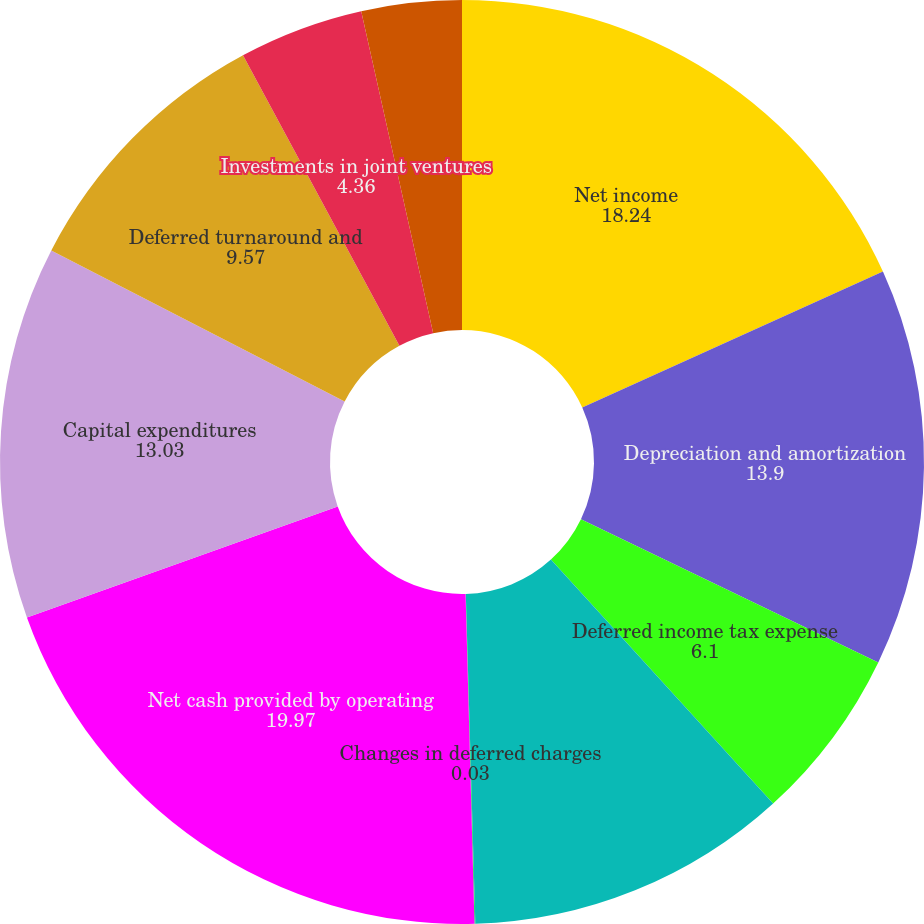<chart> <loc_0><loc_0><loc_500><loc_500><pie_chart><fcel>Net income<fcel>Depreciation and amortization<fcel>Deferred income tax expense<fcel>Changes in current assets and<fcel>Changes in deferred charges<fcel>Net cash provided by operating<fcel>Capital expenditures<fcel>Deferred turnaround and<fcel>Investments in joint ventures<fcel>Other investing activities net<nl><fcel>18.24%<fcel>13.9%<fcel>6.1%<fcel>11.3%<fcel>0.03%<fcel>19.97%<fcel>13.03%<fcel>9.57%<fcel>4.36%<fcel>3.5%<nl></chart> 